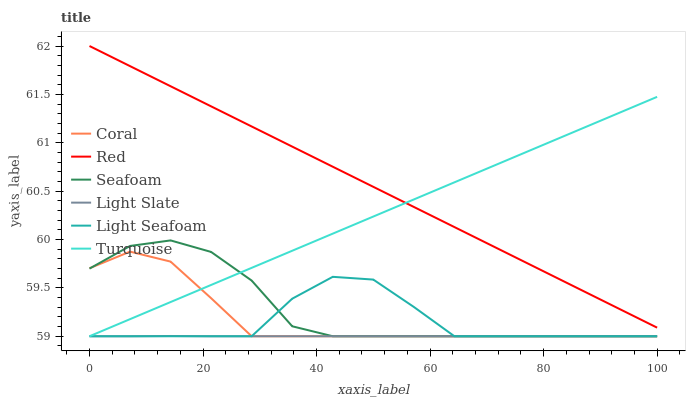Does Light Slate have the minimum area under the curve?
Answer yes or no. Yes. Does Red have the maximum area under the curve?
Answer yes or no. Yes. Does Coral have the minimum area under the curve?
Answer yes or no. No. Does Coral have the maximum area under the curve?
Answer yes or no. No. Is Red the smoothest?
Answer yes or no. Yes. Is Light Seafoam the roughest?
Answer yes or no. Yes. Is Light Slate the smoothest?
Answer yes or no. No. Is Light Slate the roughest?
Answer yes or no. No. Does Red have the lowest value?
Answer yes or no. No. Does Red have the highest value?
Answer yes or no. Yes. Does Coral have the highest value?
Answer yes or no. No. Is Coral less than Red?
Answer yes or no. Yes. Is Red greater than Seafoam?
Answer yes or no. Yes. Does Coral intersect Seafoam?
Answer yes or no. Yes. Is Coral less than Seafoam?
Answer yes or no. No. Is Coral greater than Seafoam?
Answer yes or no. No. Does Coral intersect Red?
Answer yes or no. No. 